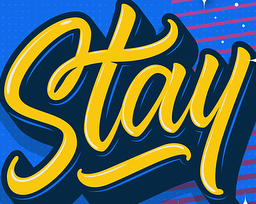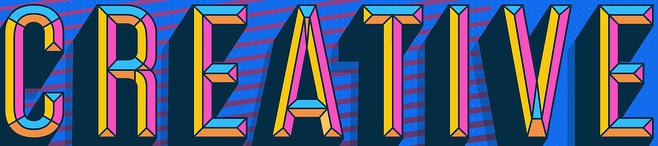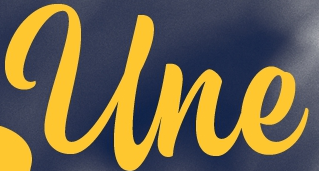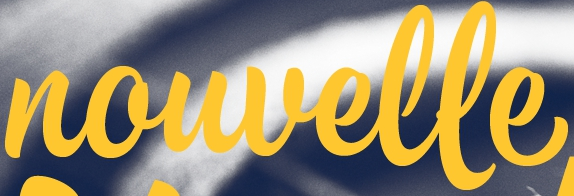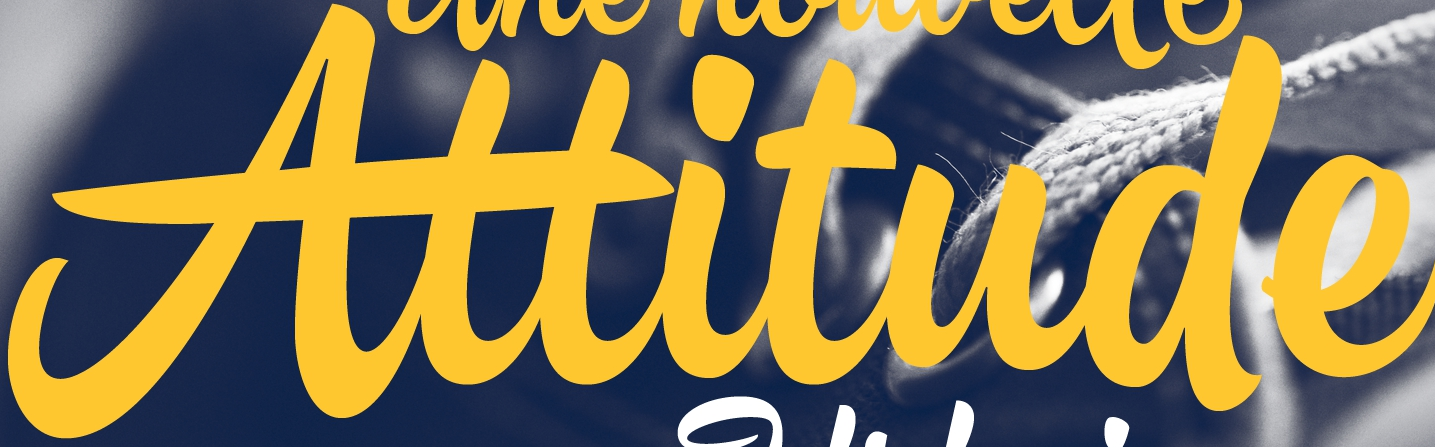Transcribe the words shown in these images in order, separated by a semicolon. Stay; CREATIVE; Une; nouvelle; Attitude 